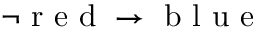<formula> <loc_0><loc_0><loc_500><loc_500>\neg r e d \rightarrow b l u e</formula> 